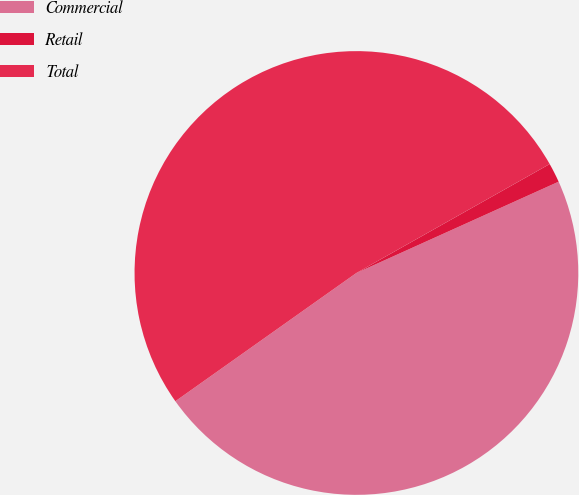<chart> <loc_0><loc_0><loc_500><loc_500><pie_chart><fcel>Commercial<fcel>Retail<fcel>Total<nl><fcel>46.94%<fcel>1.42%<fcel>51.64%<nl></chart> 